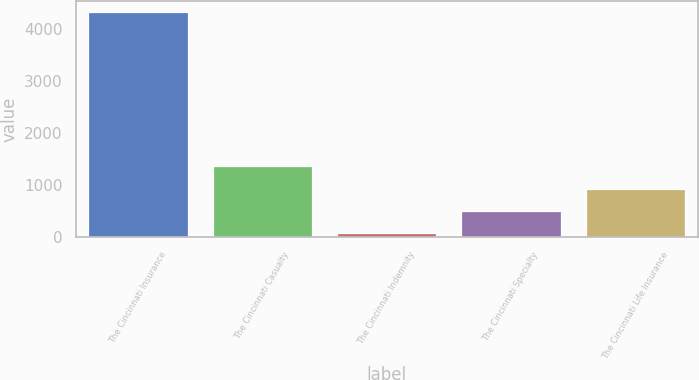Convert chart to OTSL. <chart><loc_0><loc_0><loc_500><loc_500><bar_chart><fcel>The Cincinnati Insurance<fcel>The Cincinnati Casualty<fcel>The Cincinnati Indemnity<fcel>The Cincinnati Specialty<fcel>The Cincinnati Life Insurance<nl><fcel>4326<fcel>1355.2<fcel>82<fcel>506.4<fcel>930.8<nl></chart> 